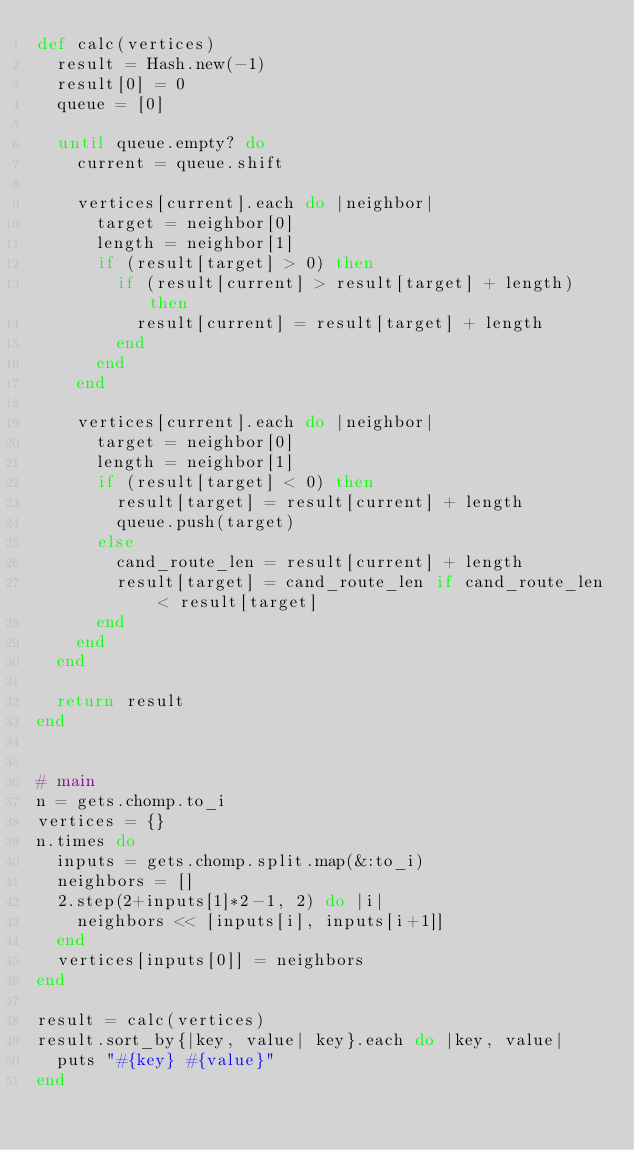<code> <loc_0><loc_0><loc_500><loc_500><_Ruby_>def calc(vertices)
  result = Hash.new(-1)
  result[0] = 0
  queue = [0] 
  
  until queue.empty? do
    current = queue.shift

    vertices[current].each do |neighbor|
      target = neighbor[0]
      length = neighbor[1]
      if (result[target] > 0) then
        if (result[current] > result[target] + length) then
          result[current] = result[target] + length
        end
      end
    end

    vertices[current].each do |neighbor|
      target = neighbor[0]
      length = neighbor[1]
      if (result[target] < 0) then
        result[target] = result[current] + length
        queue.push(target)
      else
        cand_route_len = result[current] + length
        result[target] = cand_route_len if cand_route_len < result[target]
      end
    end
  end

  return result 
end


# main
n = gets.chomp.to_i
vertices = {}
n.times do
  inputs = gets.chomp.split.map(&:to_i)
  neighbors = []
  2.step(2+inputs[1]*2-1, 2) do |i|
    neighbors << [inputs[i], inputs[i+1]]
  end
  vertices[inputs[0]] = neighbors
end

result = calc(vertices)
result.sort_by{|key, value| key}.each do |key, value|
  puts "#{key} #{value}"
end</code> 